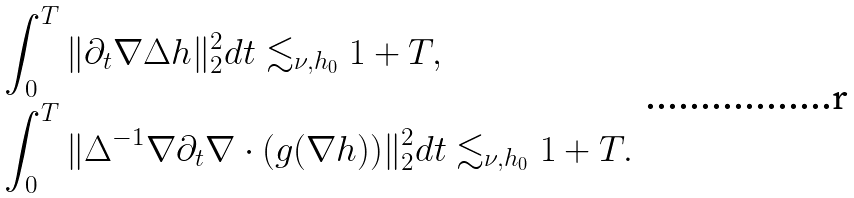<formula> <loc_0><loc_0><loc_500><loc_500>& \int _ { 0 } ^ { T } \| \partial _ { t } \nabla \Delta h \| _ { 2 } ^ { 2 } d t \lesssim _ { \nu , h _ { 0 } } 1 + T , \\ & \int _ { 0 } ^ { T } \| \Delta ^ { - 1 } \nabla \partial _ { t } \nabla \cdot ( g ( \nabla h ) ) \| _ { 2 } ^ { 2 } d t \lesssim _ { \nu , h _ { 0 } } 1 + T .</formula> 